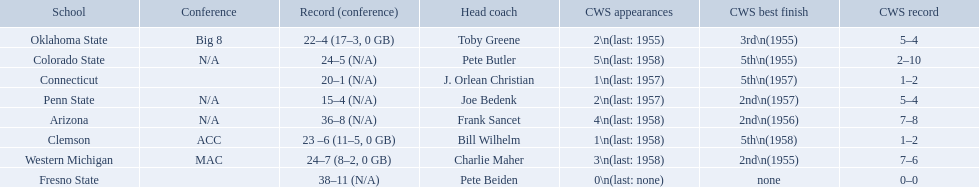What are the teams in the conference? Arizona, Clemson, Colorado State, Connecticut, Fresno State, Oklahoma State, Penn State, Western Michigan. Which have more than 16 wins? Arizona, Clemson, Colorado State, Connecticut, Fresno State, Oklahoma State, Western Michigan. Which had less than 16 wins? Penn State. 